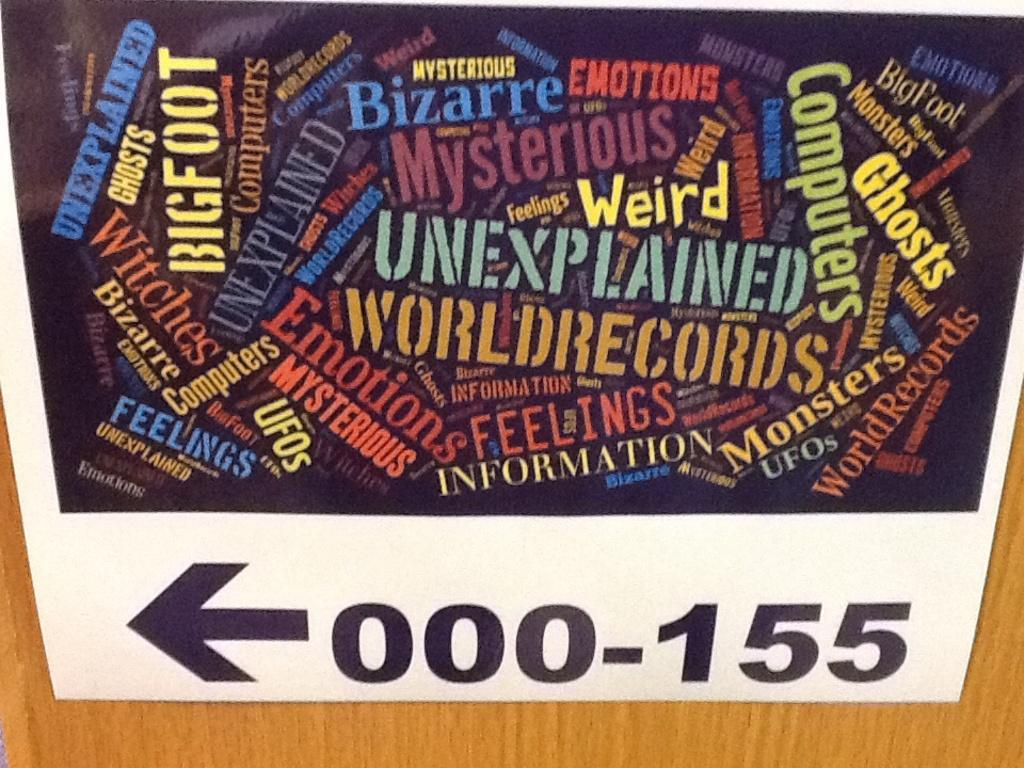<image>
Summarize the visual content of the image. A sign with an arrow points to 000 through 155. 